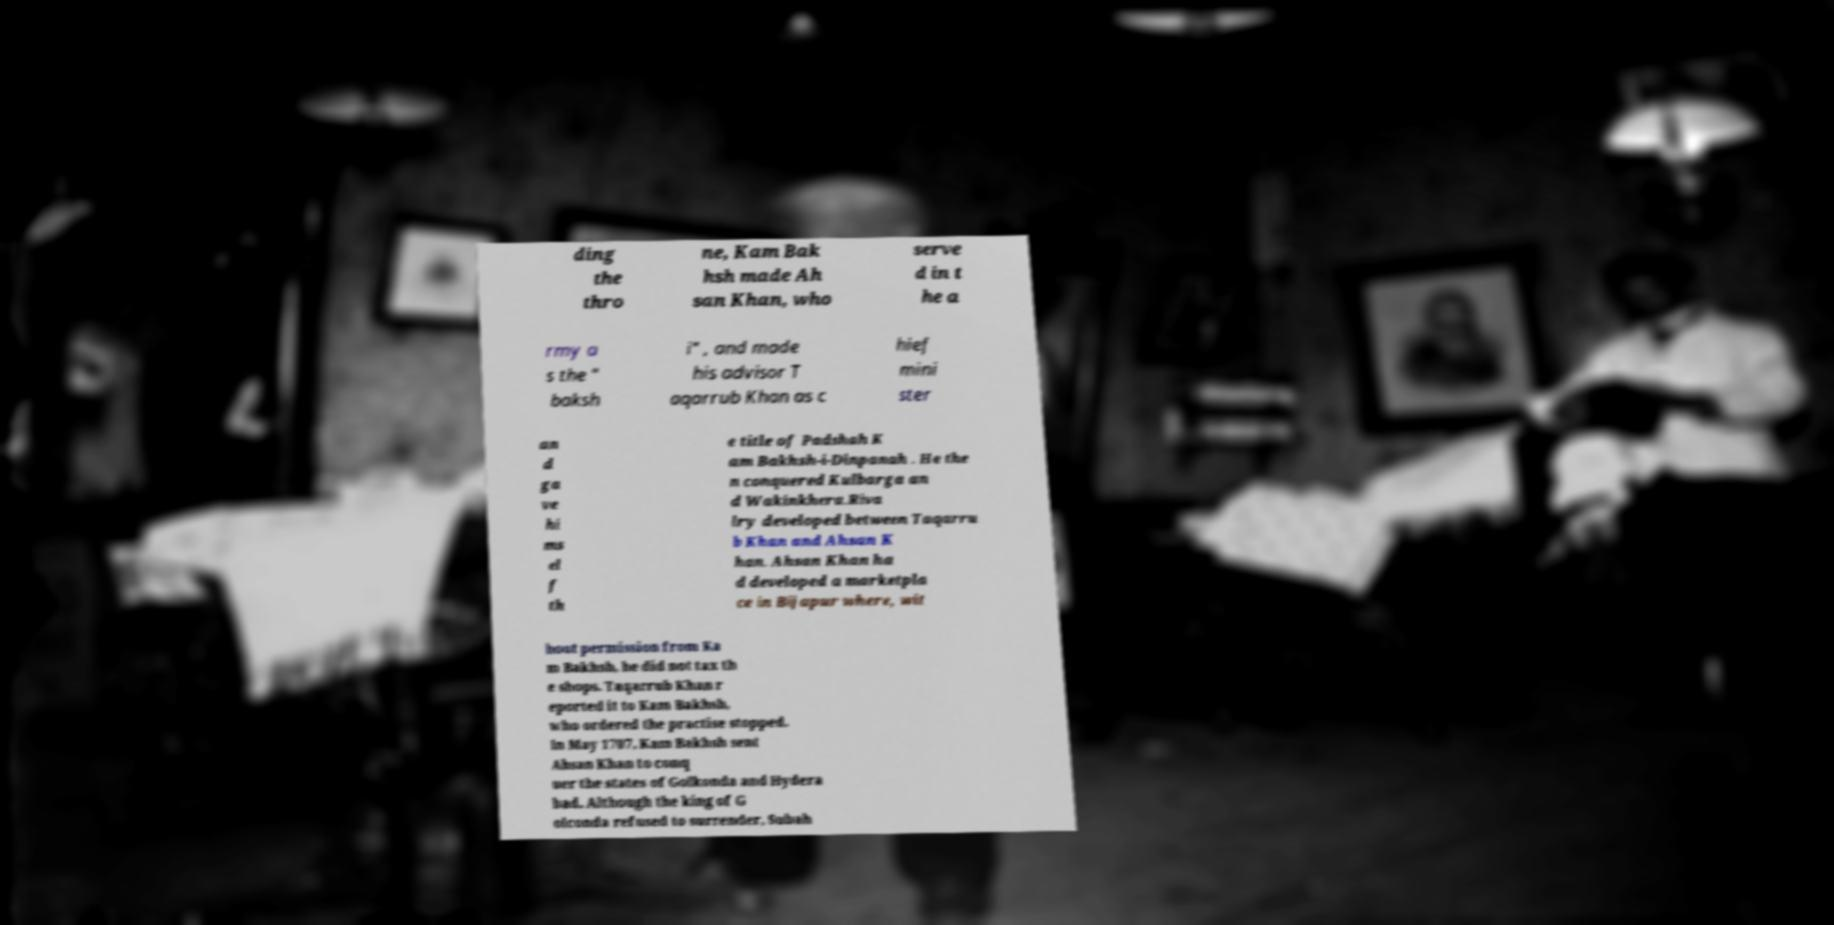Please identify and transcribe the text found in this image. ding the thro ne, Kam Bak hsh made Ah san Khan, who serve d in t he a rmy a s the " baksh i" , and made his advisor T aqarrub Khan as c hief mini ster an d ga ve hi ms el f th e title of Padshah K am Bakhsh-i-Dinpanah . He the n conquered Kulbarga an d Wakinkhera.Riva lry developed between Taqarru b Khan and Ahsan K han. Ahsan Khan ha d developed a marketpla ce in Bijapur where, wit hout permission from Ka m Bakhsh, he did not tax th e shops. Taqarrub Khan r eported it to Kam Bakhsh, who ordered the practise stopped. In May 1707, Kam Bakhsh sent Ahsan Khan to conq uer the states of Golkonda and Hydera bad. Although the king of G olconda refused to surrender, Subah 